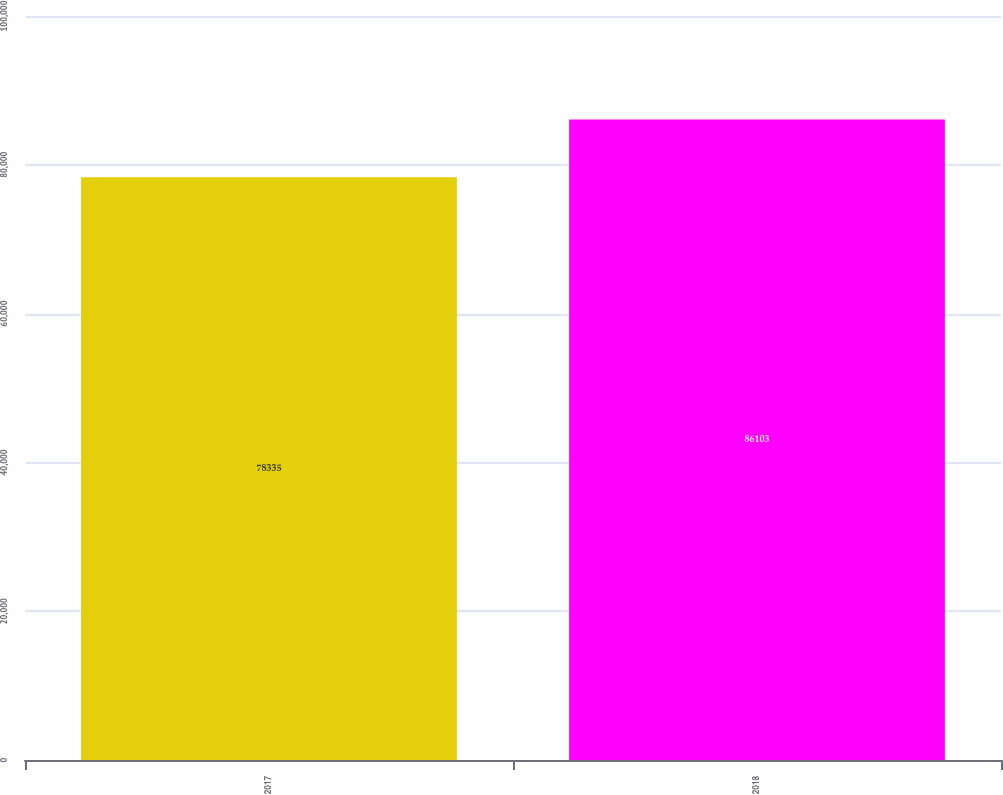Convert chart to OTSL. <chart><loc_0><loc_0><loc_500><loc_500><bar_chart><fcel>2017<fcel>2018<nl><fcel>78335<fcel>86103<nl></chart> 